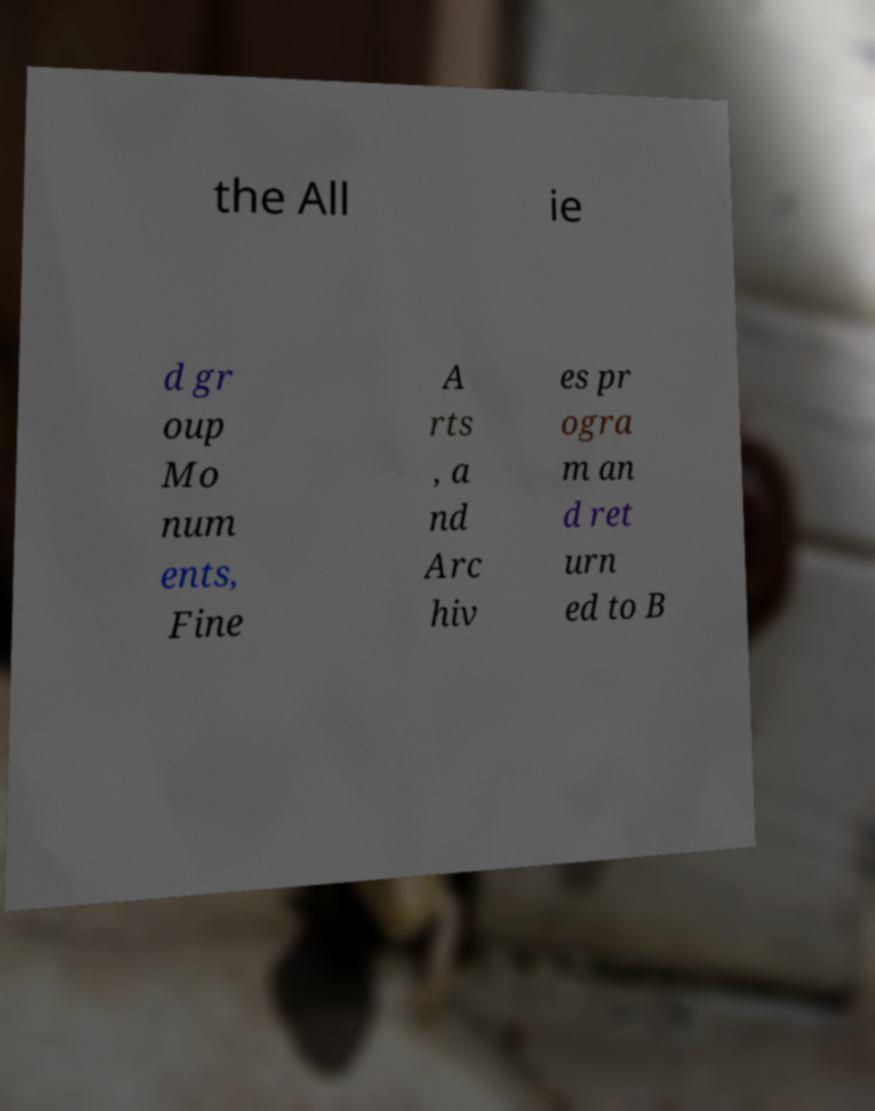Please read and relay the text visible in this image. What does it say? the All ie d gr oup Mo num ents, Fine A rts , a nd Arc hiv es pr ogra m an d ret urn ed to B 